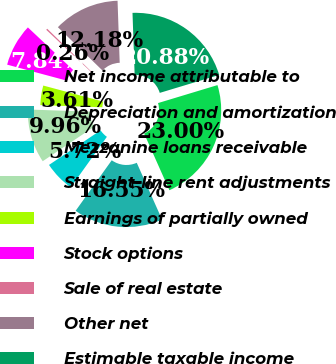<chart> <loc_0><loc_0><loc_500><loc_500><pie_chart><fcel>Net income attributable to<fcel>Depreciation and amortization<fcel>Mezzanine loans receivable<fcel>Straight-line rent adjustments<fcel>Earnings of partially owned<fcel>Stock options<fcel>Sale of real estate<fcel>Other net<fcel>Estimable taxable income<nl><fcel>23.0%<fcel>16.55%<fcel>5.72%<fcel>9.96%<fcel>3.61%<fcel>7.84%<fcel>0.26%<fcel>12.18%<fcel>20.88%<nl></chart> 